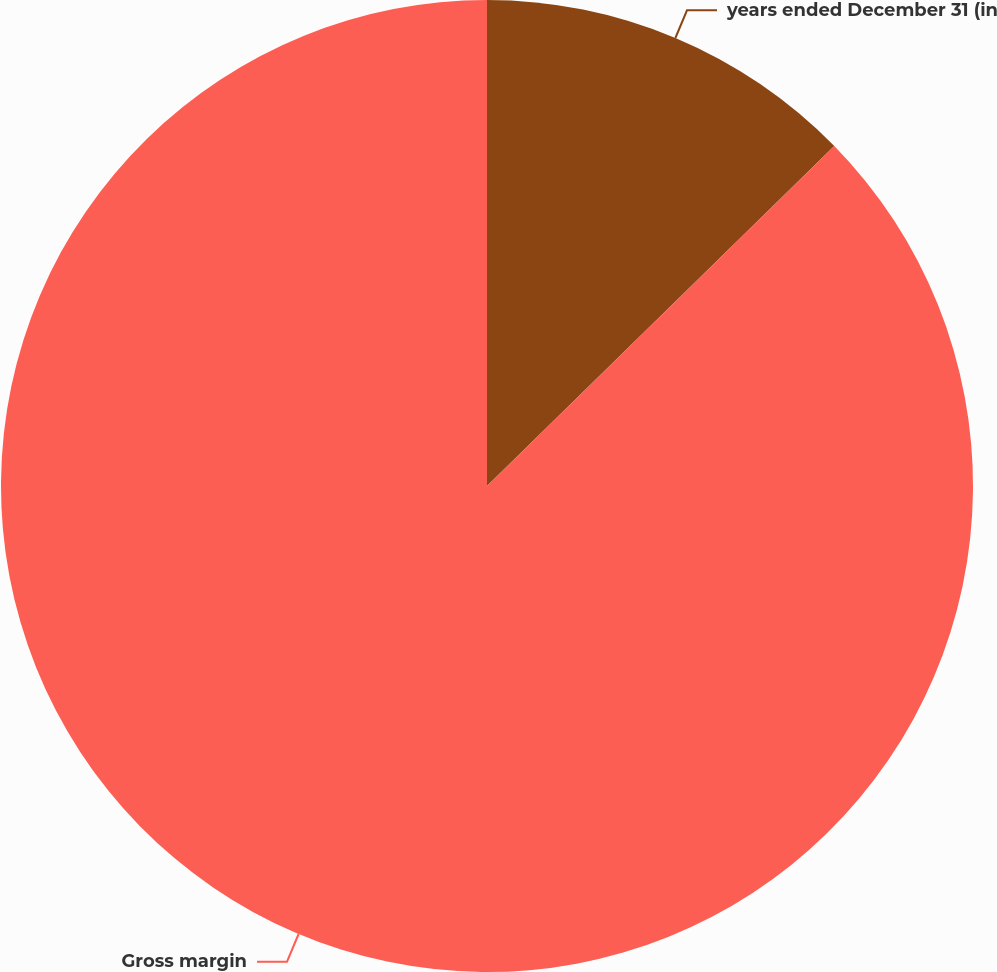<chart> <loc_0><loc_0><loc_500><loc_500><pie_chart><fcel>years ended December 31 (in<fcel>Gross margin<nl><fcel>12.67%<fcel>87.33%<nl></chart> 